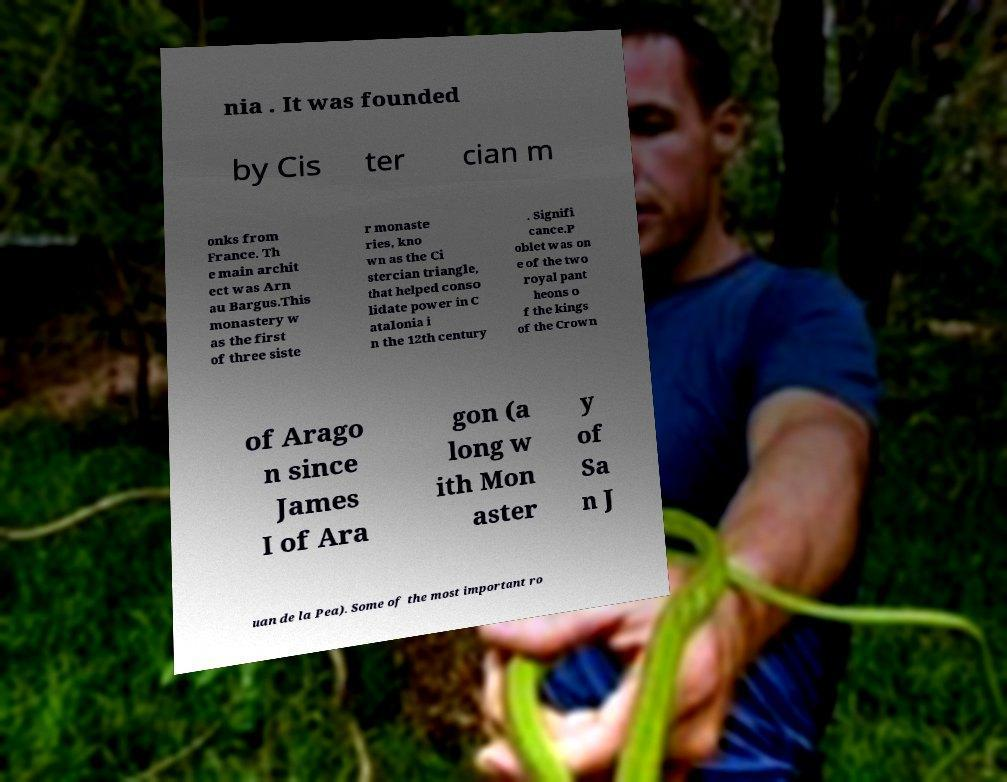Can you read and provide the text displayed in the image?This photo seems to have some interesting text. Can you extract and type it out for me? nia . It was founded by Cis ter cian m onks from France. Th e main archit ect was Arn au Bargus.This monastery w as the first of three siste r monaste ries, kno wn as the Ci stercian triangle, that helped conso lidate power in C atalonia i n the 12th century . Signifi cance.P oblet was on e of the two royal pant heons o f the kings of the Crown of Arago n since James I of Ara gon (a long w ith Mon aster y of Sa n J uan de la Pea). Some of the most important ro 